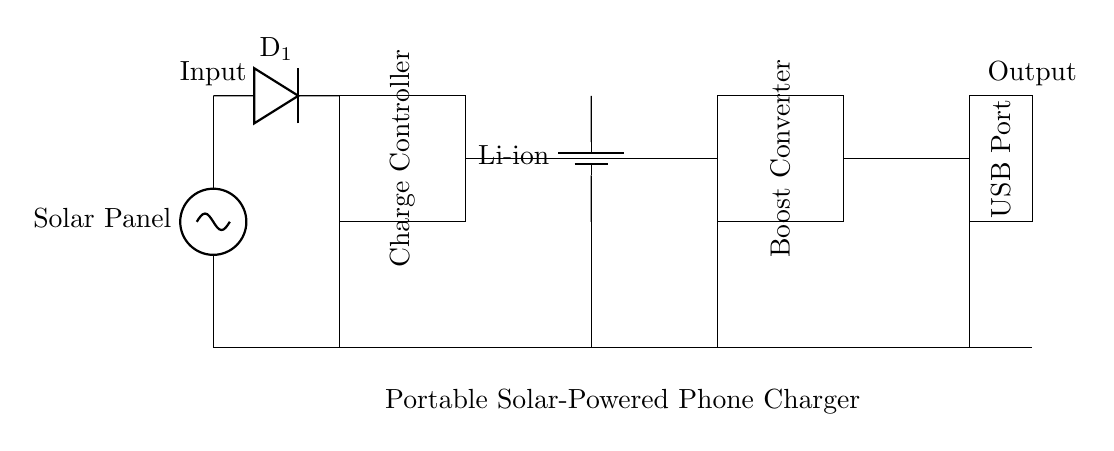What is the main source of power in this circuit? The main source of power is the solar panel, which collects sunlight and converts it into electrical energy.
Answer: Solar Panel What type of battery is used in this circuit? The battery used in this circuit is a lithium-ion battery, as indicated in the diagram.
Answer: Li-ion What component prevents reverse current flow? The component that prevents reverse current flow in this circuit is the diode, which only allows current to flow in one direction.
Answer: D1 How many main functional blocks are present in this charger circuit? The main functional blocks in this charger circuit are five: the solar panel, diode, charge controller, battery, and boost converter.
Answer: Five What component is responsible for increasing voltage to charge the phone? The boost converter is responsible for increasing the voltage to ensure that the phone can be charged at the required level.
Answer: Boost Converter What is the output connection type for charging devices? The output connection type for charging devices in this circuit is a USB port, which is standard for most mobile devices.
Answer: USB Port 